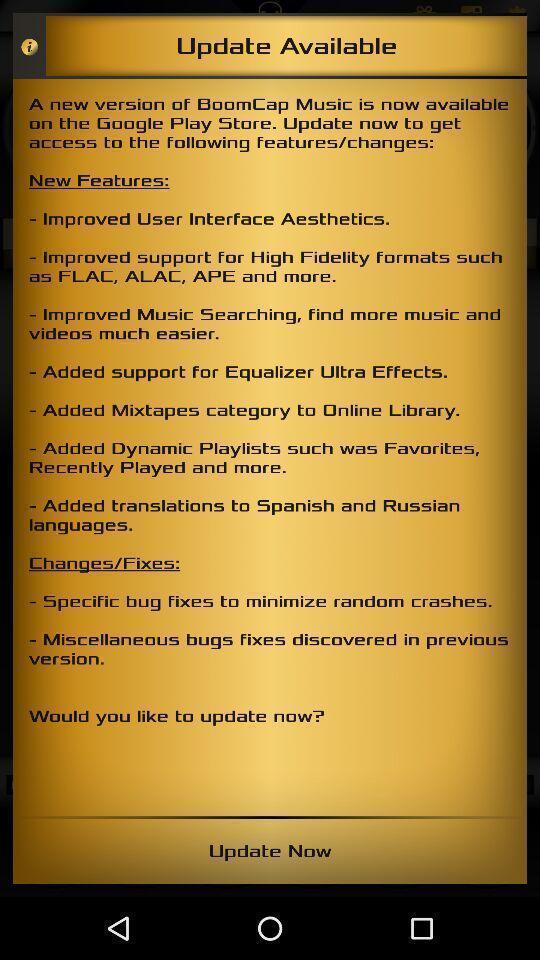Describe the key features of this screenshot. Update information. 